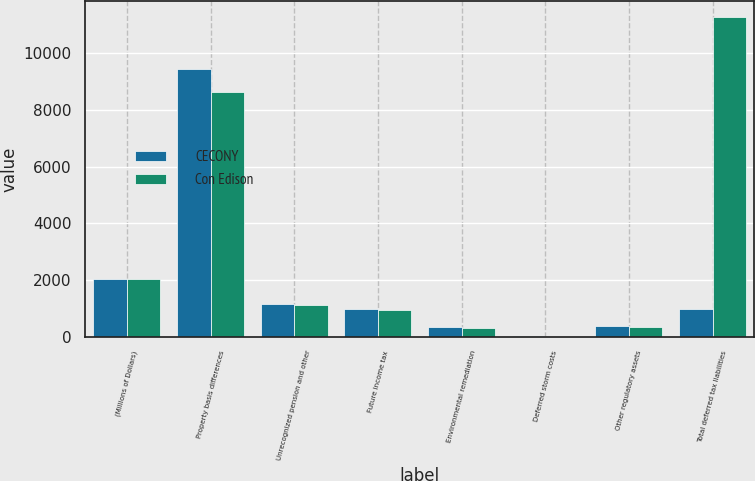Convert chart. <chart><loc_0><loc_0><loc_500><loc_500><stacked_bar_chart><ecel><fcel>(Millions of Dollars)<fcel>Property basis differences<fcel>Unrecognized pension and other<fcel>Future income tax<fcel>Environmental remediation<fcel>Deferred storm costs<fcel>Other regulatory assets<fcel>Total deferred tax liabilities<nl><fcel>CECONY<fcel>2016<fcel>9446<fcel>1162<fcel>986<fcel>333<fcel>23<fcel>371<fcel>986<nl><fcel>Con Edison<fcel>2016<fcel>8620<fcel>1104<fcel>940<fcel>287<fcel>1<fcel>321<fcel>11273<nl></chart> 